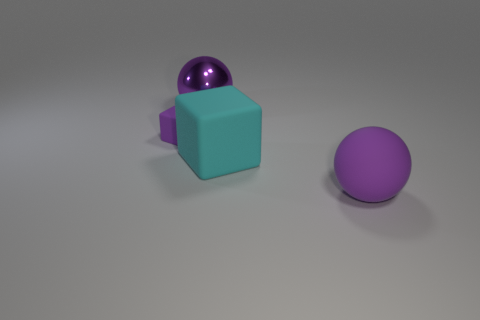Add 1 rubber balls. How many objects exist? 5 Subtract 0 blue cubes. How many objects are left? 4 Subtract all purple matte cubes. Subtract all purple metal balls. How many objects are left? 2 Add 2 purple metallic objects. How many purple metallic objects are left? 3 Add 2 big cylinders. How many big cylinders exist? 2 